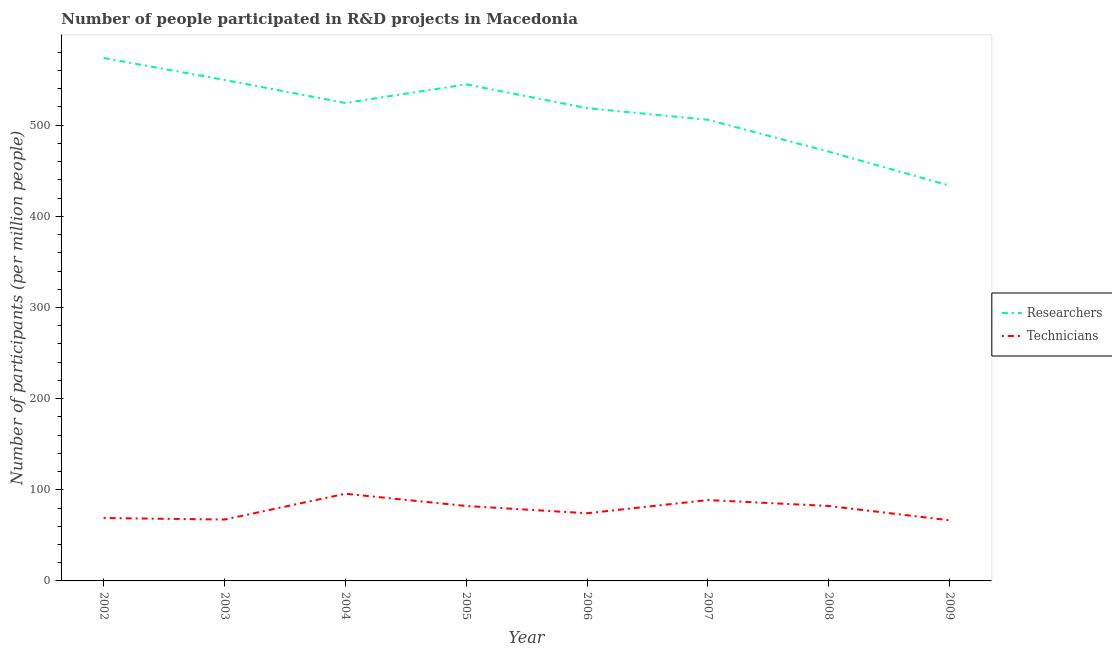Does the line corresponding to number of researchers intersect with the line corresponding to number of technicians?
Give a very brief answer. No. What is the number of technicians in 2007?
Offer a terse response. 88.72. Across all years, what is the maximum number of technicians?
Provide a short and direct response. 95.66. Across all years, what is the minimum number of researchers?
Provide a succinct answer. 433.72. In which year was the number of technicians maximum?
Offer a terse response. 2004. In which year was the number of researchers minimum?
Provide a short and direct response. 2009. What is the total number of technicians in the graph?
Offer a terse response. 625.99. What is the difference between the number of technicians in 2004 and that in 2006?
Give a very brief answer. 21.42. What is the difference between the number of technicians in 2003 and the number of researchers in 2002?
Give a very brief answer. -506.41. What is the average number of researchers per year?
Your answer should be very brief. 515.26. In the year 2004, what is the difference between the number of researchers and number of technicians?
Ensure brevity in your answer.  428.76. In how many years, is the number of technicians greater than 380?
Provide a succinct answer. 0. What is the ratio of the number of technicians in 2002 to that in 2009?
Make the answer very short. 1.04. Is the number of technicians in 2002 less than that in 2004?
Ensure brevity in your answer.  Yes. Is the difference between the number of technicians in 2002 and 2004 greater than the difference between the number of researchers in 2002 and 2004?
Offer a very short reply. No. What is the difference between the highest and the second highest number of researchers?
Make the answer very short. 24.1. What is the difference between the highest and the lowest number of technicians?
Offer a terse response. 29.12. Does the number of researchers monotonically increase over the years?
Keep it short and to the point. No. Does the graph contain any zero values?
Your response must be concise. No. Does the graph contain grids?
Provide a short and direct response. No. Where does the legend appear in the graph?
Your response must be concise. Center right. How are the legend labels stacked?
Your answer should be compact. Vertical. What is the title of the graph?
Ensure brevity in your answer.  Number of people participated in R&D projects in Macedonia. What is the label or title of the Y-axis?
Offer a terse response. Number of participants (per million people). What is the Number of participants (per million people) of Researchers in 2002?
Offer a terse response. 573.76. What is the Number of participants (per million people) in Technicians in 2002?
Keep it short and to the point. 69.01. What is the Number of participants (per million people) of Researchers in 2003?
Your answer should be compact. 549.66. What is the Number of participants (per million people) of Technicians in 2003?
Ensure brevity in your answer.  67.36. What is the Number of participants (per million people) of Researchers in 2004?
Offer a terse response. 524.42. What is the Number of participants (per million people) of Technicians in 2004?
Provide a succinct answer. 95.66. What is the Number of participants (per million people) in Researchers in 2005?
Provide a short and direct response. 544.82. What is the Number of participants (per million people) in Technicians in 2005?
Offer a very short reply. 82.24. What is the Number of participants (per million people) of Researchers in 2006?
Offer a very short reply. 518.72. What is the Number of participants (per million people) in Technicians in 2006?
Your answer should be compact. 74.24. What is the Number of participants (per million people) in Researchers in 2007?
Ensure brevity in your answer.  505.99. What is the Number of participants (per million people) in Technicians in 2007?
Offer a very short reply. 88.72. What is the Number of participants (per million people) in Researchers in 2008?
Your answer should be compact. 470.99. What is the Number of participants (per million people) in Technicians in 2008?
Make the answer very short. 82.23. What is the Number of participants (per million people) of Researchers in 2009?
Keep it short and to the point. 433.72. What is the Number of participants (per million people) in Technicians in 2009?
Make the answer very short. 66.54. Across all years, what is the maximum Number of participants (per million people) in Researchers?
Give a very brief answer. 573.76. Across all years, what is the maximum Number of participants (per million people) in Technicians?
Ensure brevity in your answer.  95.66. Across all years, what is the minimum Number of participants (per million people) of Researchers?
Give a very brief answer. 433.72. Across all years, what is the minimum Number of participants (per million people) of Technicians?
Your answer should be compact. 66.54. What is the total Number of participants (per million people) in Researchers in the graph?
Make the answer very short. 4122.08. What is the total Number of participants (per million people) in Technicians in the graph?
Your answer should be very brief. 625.99. What is the difference between the Number of participants (per million people) in Researchers in 2002 and that in 2003?
Your answer should be very brief. 24.1. What is the difference between the Number of participants (per million people) of Technicians in 2002 and that in 2003?
Offer a very short reply. 1.65. What is the difference between the Number of participants (per million people) in Researchers in 2002 and that in 2004?
Give a very brief answer. 49.35. What is the difference between the Number of participants (per million people) of Technicians in 2002 and that in 2004?
Offer a terse response. -26.65. What is the difference between the Number of participants (per million people) in Researchers in 2002 and that in 2005?
Give a very brief answer. 28.95. What is the difference between the Number of participants (per million people) in Technicians in 2002 and that in 2005?
Your answer should be very brief. -13.23. What is the difference between the Number of participants (per million people) of Researchers in 2002 and that in 2006?
Give a very brief answer. 55.04. What is the difference between the Number of participants (per million people) of Technicians in 2002 and that in 2006?
Make the answer very short. -5.23. What is the difference between the Number of participants (per million people) of Researchers in 2002 and that in 2007?
Give a very brief answer. 67.78. What is the difference between the Number of participants (per million people) of Technicians in 2002 and that in 2007?
Your answer should be very brief. -19.71. What is the difference between the Number of participants (per million people) of Researchers in 2002 and that in 2008?
Ensure brevity in your answer.  102.78. What is the difference between the Number of participants (per million people) in Technicians in 2002 and that in 2008?
Keep it short and to the point. -13.22. What is the difference between the Number of participants (per million people) of Researchers in 2002 and that in 2009?
Keep it short and to the point. 140.04. What is the difference between the Number of participants (per million people) in Technicians in 2002 and that in 2009?
Your response must be concise. 2.47. What is the difference between the Number of participants (per million people) of Researchers in 2003 and that in 2004?
Provide a succinct answer. 25.24. What is the difference between the Number of participants (per million people) in Technicians in 2003 and that in 2004?
Offer a terse response. -28.31. What is the difference between the Number of participants (per million people) in Researchers in 2003 and that in 2005?
Your answer should be very brief. 4.85. What is the difference between the Number of participants (per million people) in Technicians in 2003 and that in 2005?
Offer a terse response. -14.88. What is the difference between the Number of participants (per million people) in Researchers in 2003 and that in 2006?
Keep it short and to the point. 30.94. What is the difference between the Number of participants (per million people) in Technicians in 2003 and that in 2006?
Keep it short and to the point. -6.89. What is the difference between the Number of participants (per million people) of Researchers in 2003 and that in 2007?
Offer a terse response. 43.67. What is the difference between the Number of participants (per million people) of Technicians in 2003 and that in 2007?
Your response must be concise. -21.36. What is the difference between the Number of participants (per million people) of Researchers in 2003 and that in 2008?
Keep it short and to the point. 78.68. What is the difference between the Number of participants (per million people) of Technicians in 2003 and that in 2008?
Make the answer very short. -14.87. What is the difference between the Number of participants (per million people) of Researchers in 2003 and that in 2009?
Ensure brevity in your answer.  115.94. What is the difference between the Number of participants (per million people) of Technicians in 2003 and that in 2009?
Provide a succinct answer. 0.82. What is the difference between the Number of participants (per million people) of Researchers in 2004 and that in 2005?
Your answer should be very brief. -20.4. What is the difference between the Number of participants (per million people) of Technicians in 2004 and that in 2005?
Your response must be concise. 13.42. What is the difference between the Number of participants (per million people) in Researchers in 2004 and that in 2006?
Give a very brief answer. 5.7. What is the difference between the Number of participants (per million people) in Technicians in 2004 and that in 2006?
Offer a very short reply. 21.42. What is the difference between the Number of participants (per million people) in Researchers in 2004 and that in 2007?
Provide a short and direct response. 18.43. What is the difference between the Number of participants (per million people) of Technicians in 2004 and that in 2007?
Provide a succinct answer. 6.94. What is the difference between the Number of participants (per million people) of Researchers in 2004 and that in 2008?
Your answer should be very brief. 53.43. What is the difference between the Number of participants (per million people) in Technicians in 2004 and that in 2008?
Your response must be concise. 13.43. What is the difference between the Number of participants (per million people) in Researchers in 2004 and that in 2009?
Make the answer very short. 90.7. What is the difference between the Number of participants (per million people) in Technicians in 2004 and that in 2009?
Your answer should be very brief. 29.12. What is the difference between the Number of participants (per million people) of Researchers in 2005 and that in 2006?
Your response must be concise. 26.09. What is the difference between the Number of participants (per million people) in Technicians in 2005 and that in 2006?
Make the answer very short. 7.99. What is the difference between the Number of participants (per million people) of Researchers in 2005 and that in 2007?
Your response must be concise. 38.83. What is the difference between the Number of participants (per million people) of Technicians in 2005 and that in 2007?
Offer a very short reply. -6.48. What is the difference between the Number of participants (per million people) of Researchers in 2005 and that in 2008?
Provide a succinct answer. 73.83. What is the difference between the Number of participants (per million people) of Technicians in 2005 and that in 2008?
Ensure brevity in your answer.  0.01. What is the difference between the Number of participants (per million people) of Researchers in 2005 and that in 2009?
Your response must be concise. 111.09. What is the difference between the Number of participants (per million people) in Technicians in 2005 and that in 2009?
Your answer should be very brief. 15.7. What is the difference between the Number of participants (per million people) of Researchers in 2006 and that in 2007?
Your answer should be very brief. 12.74. What is the difference between the Number of participants (per million people) of Technicians in 2006 and that in 2007?
Your answer should be compact. -14.48. What is the difference between the Number of participants (per million people) in Researchers in 2006 and that in 2008?
Your answer should be very brief. 47.74. What is the difference between the Number of participants (per million people) in Technicians in 2006 and that in 2008?
Your answer should be compact. -7.98. What is the difference between the Number of participants (per million people) in Researchers in 2006 and that in 2009?
Your answer should be very brief. 85. What is the difference between the Number of participants (per million people) in Technicians in 2006 and that in 2009?
Your answer should be compact. 7.7. What is the difference between the Number of participants (per million people) in Researchers in 2007 and that in 2008?
Your answer should be very brief. 35. What is the difference between the Number of participants (per million people) in Technicians in 2007 and that in 2008?
Keep it short and to the point. 6.49. What is the difference between the Number of participants (per million people) in Researchers in 2007 and that in 2009?
Your answer should be very brief. 72.27. What is the difference between the Number of participants (per million people) in Technicians in 2007 and that in 2009?
Ensure brevity in your answer.  22.18. What is the difference between the Number of participants (per million people) in Researchers in 2008 and that in 2009?
Provide a short and direct response. 37.26. What is the difference between the Number of participants (per million people) of Technicians in 2008 and that in 2009?
Your answer should be compact. 15.69. What is the difference between the Number of participants (per million people) of Researchers in 2002 and the Number of participants (per million people) of Technicians in 2003?
Ensure brevity in your answer.  506.41. What is the difference between the Number of participants (per million people) of Researchers in 2002 and the Number of participants (per million people) of Technicians in 2004?
Ensure brevity in your answer.  478.1. What is the difference between the Number of participants (per million people) in Researchers in 2002 and the Number of participants (per million people) in Technicians in 2005?
Your answer should be compact. 491.53. What is the difference between the Number of participants (per million people) in Researchers in 2002 and the Number of participants (per million people) in Technicians in 2006?
Offer a very short reply. 499.52. What is the difference between the Number of participants (per million people) of Researchers in 2002 and the Number of participants (per million people) of Technicians in 2007?
Offer a terse response. 485.05. What is the difference between the Number of participants (per million people) of Researchers in 2002 and the Number of participants (per million people) of Technicians in 2008?
Provide a succinct answer. 491.54. What is the difference between the Number of participants (per million people) in Researchers in 2002 and the Number of participants (per million people) in Technicians in 2009?
Make the answer very short. 507.23. What is the difference between the Number of participants (per million people) in Researchers in 2003 and the Number of participants (per million people) in Technicians in 2004?
Your answer should be very brief. 454. What is the difference between the Number of participants (per million people) in Researchers in 2003 and the Number of participants (per million people) in Technicians in 2005?
Offer a terse response. 467.43. What is the difference between the Number of participants (per million people) of Researchers in 2003 and the Number of participants (per million people) of Technicians in 2006?
Offer a very short reply. 475.42. What is the difference between the Number of participants (per million people) of Researchers in 2003 and the Number of participants (per million people) of Technicians in 2007?
Make the answer very short. 460.94. What is the difference between the Number of participants (per million people) of Researchers in 2003 and the Number of participants (per million people) of Technicians in 2008?
Provide a short and direct response. 467.44. What is the difference between the Number of participants (per million people) in Researchers in 2003 and the Number of participants (per million people) in Technicians in 2009?
Your answer should be very brief. 483.12. What is the difference between the Number of participants (per million people) in Researchers in 2004 and the Number of participants (per million people) in Technicians in 2005?
Make the answer very short. 442.18. What is the difference between the Number of participants (per million people) of Researchers in 2004 and the Number of participants (per million people) of Technicians in 2006?
Your answer should be very brief. 450.18. What is the difference between the Number of participants (per million people) in Researchers in 2004 and the Number of participants (per million people) in Technicians in 2007?
Keep it short and to the point. 435.7. What is the difference between the Number of participants (per million people) of Researchers in 2004 and the Number of participants (per million people) of Technicians in 2008?
Keep it short and to the point. 442.19. What is the difference between the Number of participants (per million people) in Researchers in 2004 and the Number of participants (per million people) in Technicians in 2009?
Your answer should be compact. 457.88. What is the difference between the Number of participants (per million people) in Researchers in 2005 and the Number of participants (per million people) in Technicians in 2006?
Provide a short and direct response. 470.57. What is the difference between the Number of participants (per million people) of Researchers in 2005 and the Number of participants (per million people) of Technicians in 2007?
Provide a short and direct response. 456.1. What is the difference between the Number of participants (per million people) of Researchers in 2005 and the Number of participants (per million people) of Technicians in 2008?
Your response must be concise. 462.59. What is the difference between the Number of participants (per million people) in Researchers in 2005 and the Number of participants (per million people) in Technicians in 2009?
Offer a terse response. 478.28. What is the difference between the Number of participants (per million people) in Researchers in 2006 and the Number of participants (per million people) in Technicians in 2007?
Provide a short and direct response. 430.01. What is the difference between the Number of participants (per million people) in Researchers in 2006 and the Number of participants (per million people) in Technicians in 2008?
Keep it short and to the point. 436.5. What is the difference between the Number of participants (per million people) of Researchers in 2006 and the Number of participants (per million people) of Technicians in 2009?
Make the answer very short. 452.18. What is the difference between the Number of participants (per million people) of Researchers in 2007 and the Number of participants (per million people) of Technicians in 2008?
Your response must be concise. 423.76. What is the difference between the Number of participants (per million people) in Researchers in 2007 and the Number of participants (per million people) in Technicians in 2009?
Keep it short and to the point. 439.45. What is the difference between the Number of participants (per million people) in Researchers in 2008 and the Number of participants (per million people) in Technicians in 2009?
Provide a short and direct response. 404.45. What is the average Number of participants (per million people) in Researchers per year?
Your response must be concise. 515.26. What is the average Number of participants (per million people) of Technicians per year?
Offer a terse response. 78.25. In the year 2002, what is the difference between the Number of participants (per million people) in Researchers and Number of participants (per million people) in Technicians?
Offer a terse response. 504.76. In the year 2003, what is the difference between the Number of participants (per million people) in Researchers and Number of participants (per million people) in Technicians?
Provide a succinct answer. 482.31. In the year 2004, what is the difference between the Number of participants (per million people) in Researchers and Number of participants (per million people) in Technicians?
Make the answer very short. 428.76. In the year 2005, what is the difference between the Number of participants (per million people) of Researchers and Number of participants (per million people) of Technicians?
Your answer should be compact. 462.58. In the year 2006, what is the difference between the Number of participants (per million people) of Researchers and Number of participants (per million people) of Technicians?
Ensure brevity in your answer.  444.48. In the year 2007, what is the difference between the Number of participants (per million people) in Researchers and Number of participants (per million people) in Technicians?
Keep it short and to the point. 417.27. In the year 2008, what is the difference between the Number of participants (per million people) of Researchers and Number of participants (per million people) of Technicians?
Offer a terse response. 388.76. In the year 2009, what is the difference between the Number of participants (per million people) of Researchers and Number of participants (per million people) of Technicians?
Offer a terse response. 367.18. What is the ratio of the Number of participants (per million people) of Researchers in 2002 to that in 2003?
Ensure brevity in your answer.  1.04. What is the ratio of the Number of participants (per million people) of Technicians in 2002 to that in 2003?
Your response must be concise. 1.02. What is the ratio of the Number of participants (per million people) in Researchers in 2002 to that in 2004?
Give a very brief answer. 1.09. What is the ratio of the Number of participants (per million people) of Technicians in 2002 to that in 2004?
Give a very brief answer. 0.72. What is the ratio of the Number of participants (per million people) in Researchers in 2002 to that in 2005?
Provide a short and direct response. 1.05. What is the ratio of the Number of participants (per million people) of Technicians in 2002 to that in 2005?
Keep it short and to the point. 0.84. What is the ratio of the Number of participants (per million people) of Researchers in 2002 to that in 2006?
Provide a short and direct response. 1.11. What is the ratio of the Number of participants (per million people) of Technicians in 2002 to that in 2006?
Ensure brevity in your answer.  0.93. What is the ratio of the Number of participants (per million people) of Researchers in 2002 to that in 2007?
Your answer should be very brief. 1.13. What is the ratio of the Number of participants (per million people) of Technicians in 2002 to that in 2007?
Keep it short and to the point. 0.78. What is the ratio of the Number of participants (per million people) of Researchers in 2002 to that in 2008?
Keep it short and to the point. 1.22. What is the ratio of the Number of participants (per million people) of Technicians in 2002 to that in 2008?
Provide a succinct answer. 0.84. What is the ratio of the Number of participants (per million people) in Researchers in 2002 to that in 2009?
Give a very brief answer. 1.32. What is the ratio of the Number of participants (per million people) of Technicians in 2002 to that in 2009?
Offer a very short reply. 1.04. What is the ratio of the Number of participants (per million people) of Researchers in 2003 to that in 2004?
Keep it short and to the point. 1.05. What is the ratio of the Number of participants (per million people) in Technicians in 2003 to that in 2004?
Your answer should be compact. 0.7. What is the ratio of the Number of participants (per million people) in Researchers in 2003 to that in 2005?
Provide a short and direct response. 1.01. What is the ratio of the Number of participants (per million people) of Technicians in 2003 to that in 2005?
Your response must be concise. 0.82. What is the ratio of the Number of participants (per million people) of Researchers in 2003 to that in 2006?
Provide a short and direct response. 1.06. What is the ratio of the Number of participants (per million people) of Technicians in 2003 to that in 2006?
Ensure brevity in your answer.  0.91. What is the ratio of the Number of participants (per million people) in Researchers in 2003 to that in 2007?
Provide a succinct answer. 1.09. What is the ratio of the Number of participants (per million people) in Technicians in 2003 to that in 2007?
Ensure brevity in your answer.  0.76. What is the ratio of the Number of participants (per million people) in Researchers in 2003 to that in 2008?
Give a very brief answer. 1.17. What is the ratio of the Number of participants (per million people) of Technicians in 2003 to that in 2008?
Make the answer very short. 0.82. What is the ratio of the Number of participants (per million people) in Researchers in 2003 to that in 2009?
Keep it short and to the point. 1.27. What is the ratio of the Number of participants (per million people) in Technicians in 2003 to that in 2009?
Offer a terse response. 1.01. What is the ratio of the Number of participants (per million people) in Researchers in 2004 to that in 2005?
Provide a short and direct response. 0.96. What is the ratio of the Number of participants (per million people) in Technicians in 2004 to that in 2005?
Make the answer very short. 1.16. What is the ratio of the Number of participants (per million people) of Researchers in 2004 to that in 2006?
Offer a very short reply. 1.01. What is the ratio of the Number of participants (per million people) of Technicians in 2004 to that in 2006?
Offer a terse response. 1.29. What is the ratio of the Number of participants (per million people) in Researchers in 2004 to that in 2007?
Your answer should be compact. 1.04. What is the ratio of the Number of participants (per million people) of Technicians in 2004 to that in 2007?
Offer a terse response. 1.08. What is the ratio of the Number of participants (per million people) in Researchers in 2004 to that in 2008?
Offer a very short reply. 1.11. What is the ratio of the Number of participants (per million people) of Technicians in 2004 to that in 2008?
Make the answer very short. 1.16. What is the ratio of the Number of participants (per million people) of Researchers in 2004 to that in 2009?
Provide a short and direct response. 1.21. What is the ratio of the Number of participants (per million people) in Technicians in 2004 to that in 2009?
Give a very brief answer. 1.44. What is the ratio of the Number of participants (per million people) of Researchers in 2005 to that in 2006?
Keep it short and to the point. 1.05. What is the ratio of the Number of participants (per million people) of Technicians in 2005 to that in 2006?
Provide a short and direct response. 1.11. What is the ratio of the Number of participants (per million people) of Researchers in 2005 to that in 2007?
Your response must be concise. 1.08. What is the ratio of the Number of participants (per million people) of Technicians in 2005 to that in 2007?
Make the answer very short. 0.93. What is the ratio of the Number of participants (per million people) of Researchers in 2005 to that in 2008?
Offer a very short reply. 1.16. What is the ratio of the Number of participants (per million people) in Technicians in 2005 to that in 2008?
Provide a short and direct response. 1. What is the ratio of the Number of participants (per million people) of Researchers in 2005 to that in 2009?
Keep it short and to the point. 1.26. What is the ratio of the Number of participants (per million people) in Technicians in 2005 to that in 2009?
Your answer should be compact. 1.24. What is the ratio of the Number of participants (per million people) of Researchers in 2006 to that in 2007?
Your response must be concise. 1.03. What is the ratio of the Number of participants (per million people) of Technicians in 2006 to that in 2007?
Your response must be concise. 0.84. What is the ratio of the Number of participants (per million people) of Researchers in 2006 to that in 2008?
Keep it short and to the point. 1.1. What is the ratio of the Number of participants (per million people) in Technicians in 2006 to that in 2008?
Offer a terse response. 0.9. What is the ratio of the Number of participants (per million people) of Researchers in 2006 to that in 2009?
Provide a short and direct response. 1.2. What is the ratio of the Number of participants (per million people) in Technicians in 2006 to that in 2009?
Your answer should be compact. 1.12. What is the ratio of the Number of participants (per million people) in Researchers in 2007 to that in 2008?
Your answer should be compact. 1.07. What is the ratio of the Number of participants (per million people) of Technicians in 2007 to that in 2008?
Offer a terse response. 1.08. What is the ratio of the Number of participants (per million people) of Researchers in 2007 to that in 2009?
Your answer should be compact. 1.17. What is the ratio of the Number of participants (per million people) of Technicians in 2007 to that in 2009?
Provide a short and direct response. 1.33. What is the ratio of the Number of participants (per million people) in Researchers in 2008 to that in 2009?
Your answer should be very brief. 1.09. What is the ratio of the Number of participants (per million people) of Technicians in 2008 to that in 2009?
Offer a terse response. 1.24. What is the difference between the highest and the second highest Number of participants (per million people) of Researchers?
Give a very brief answer. 24.1. What is the difference between the highest and the second highest Number of participants (per million people) in Technicians?
Your response must be concise. 6.94. What is the difference between the highest and the lowest Number of participants (per million people) of Researchers?
Give a very brief answer. 140.04. What is the difference between the highest and the lowest Number of participants (per million people) in Technicians?
Offer a terse response. 29.12. 